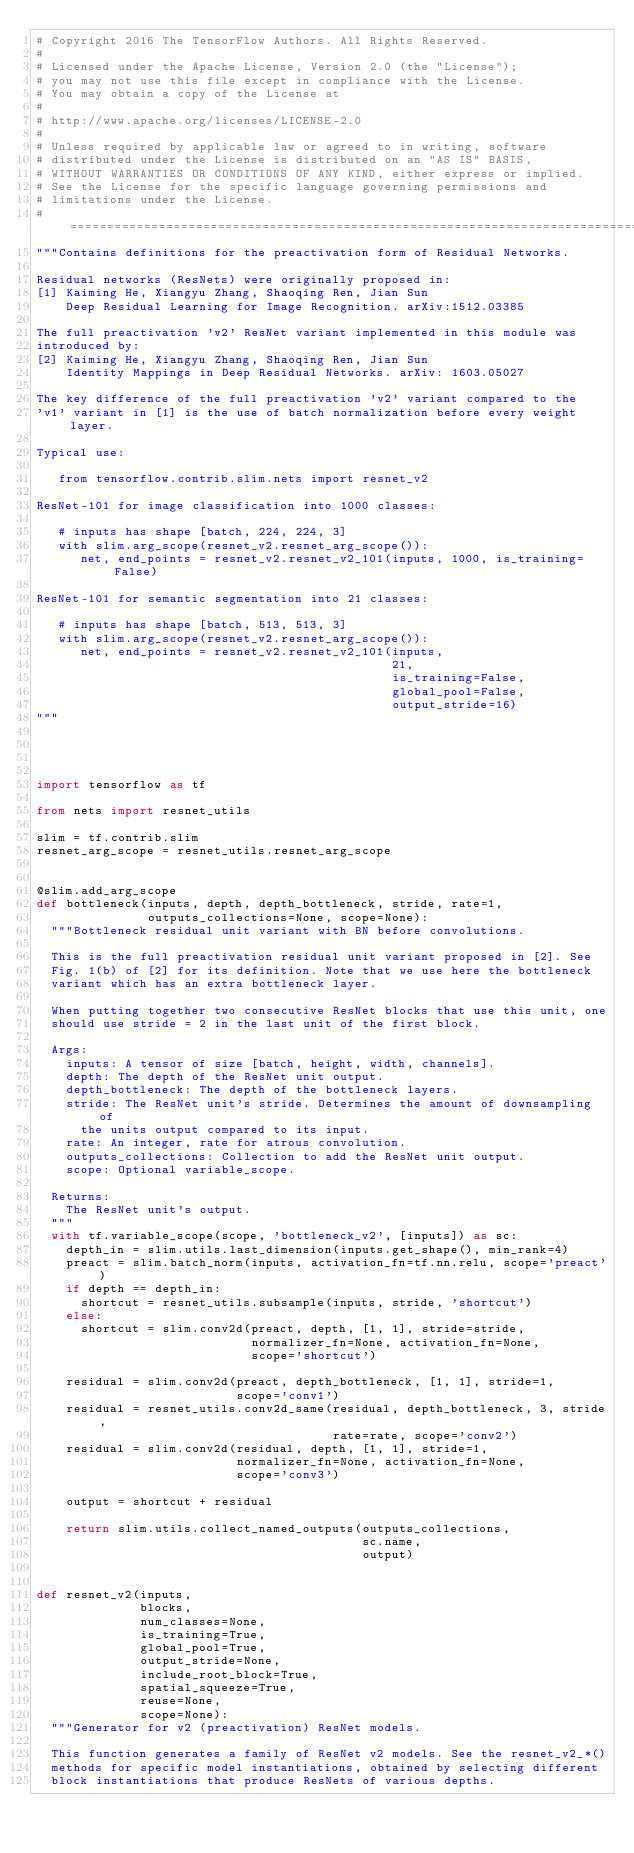Convert code to text. <code><loc_0><loc_0><loc_500><loc_500><_Python_># Copyright 2016 The TensorFlow Authors. All Rights Reserved.
#
# Licensed under the Apache License, Version 2.0 (the "License");
# you may not use this file except in compliance with the License.
# You may obtain a copy of the License at
#
# http://www.apache.org/licenses/LICENSE-2.0
#
# Unless required by applicable law or agreed to in writing, software
# distributed under the License is distributed on an "AS IS" BASIS,
# WITHOUT WARRANTIES OR CONDITIONS OF ANY KIND, either express or implied.
# See the License for the specific language governing permissions and
# limitations under the License.
# ==============================================================================
"""Contains definitions for the preactivation form of Residual Networks.

Residual networks (ResNets) were originally proposed in:
[1] Kaiming He, Xiangyu Zhang, Shaoqing Ren, Jian Sun
    Deep Residual Learning for Image Recognition. arXiv:1512.03385

The full preactivation 'v2' ResNet variant implemented in this module was
introduced by:
[2] Kaiming He, Xiangyu Zhang, Shaoqing Ren, Jian Sun
    Identity Mappings in Deep Residual Networks. arXiv: 1603.05027

The key difference of the full preactivation 'v2' variant compared to the
'v1' variant in [1] is the use of batch normalization before every weight layer.

Typical use:

   from tensorflow.contrib.slim.nets import resnet_v2

ResNet-101 for image classification into 1000 classes:

   # inputs has shape [batch, 224, 224, 3]
   with slim.arg_scope(resnet_v2.resnet_arg_scope()):
      net, end_points = resnet_v2.resnet_v2_101(inputs, 1000, is_training=False)

ResNet-101 for semantic segmentation into 21 classes:

   # inputs has shape [batch, 513, 513, 3]
   with slim.arg_scope(resnet_v2.resnet_arg_scope()):
      net, end_points = resnet_v2.resnet_v2_101(inputs,
                                                21,
                                                is_training=False,
                                                global_pool=False,
                                                output_stride=16)
"""




import tensorflow as tf

from nets import resnet_utils

slim = tf.contrib.slim
resnet_arg_scope = resnet_utils.resnet_arg_scope


@slim.add_arg_scope
def bottleneck(inputs, depth, depth_bottleneck, stride, rate=1,
               outputs_collections=None, scope=None):
  """Bottleneck residual unit variant with BN before convolutions.

  This is the full preactivation residual unit variant proposed in [2]. See
  Fig. 1(b) of [2] for its definition. Note that we use here the bottleneck
  variant which has an extra bottleneck layer.

  When putting together two consecutive ResNet blocks that use this unit, one
  should use stride = 2 in the last unit of the first block.

  Args:
    inputs: A tensor of size [batch, height, width, channels].
    depth: The depth of the ResNet unit output.
    depth_bottleneck: The depth of the bottleneck layers.
    stride: The ResNet unit's stride. Determines the amount of downsampling of
      the units output compared to its input.
    rate: An integer, rate for atrous convolution.
    outputs_collections: Collection to add the ResNet unit output.
    scope: Optional variable_scope.

  Returns:
    The ResNet unit's output.
  """
  with tf.variable_scope(scope, 'bottleneck_v2', [inputs]) as sc:
    depth_in = slim.utils.last_dimension(inputs.get_shape(), min_rank=4)
    preact = slim.batch_norm(inputs, activation_fn=tf.nn.relu, scope='preact')
    if depth == depth_in:
      shortcut = resnet_utils.subsample(inputs, stride, 'shortcut')
    else:
      shortcut = slim.conv2d(preact, depth, [1, 1], stride=stride,
                             normalizer_fn=None, activation_fn=None,
                             scope='shortcut')

    residual = slim.conv2d(preact, depth_bottleneck, [1, 1], stride=1,
                           scope='conv1')
    residual = resnet_utils.conv2d_same(residual, depth_bottleneck, 3, stride,
                                        rate=rate, scope='conv2')
    residual = slim.conv2d(residual, depth, [1, 1], stride=1,
                           normalizer_fn=None, activation_fn=None,
                           scope='conv3')

    output = shortcut + residual

    return slim.utils.collect_named_outputs(outputs_collections,
                                            sc.name,
                                            output)


def resnet_v2(inputs,
              blocks,
              num_classes=None,
              is_training=True,
              global_pool=True,
              output_stride=None,
              include_root_block=True,
              spatial_squeeze=True,
              reuse=None,
              scope=None):
  """Generator for v2 (preactivation) ResNet models.

  This function generates a family of ResNet v2 models. See the resnet_v2_*()
  methods for specific model instantiations, obtained by selecting different
  block instantiations that produce ResNets of various depths.
</code> 